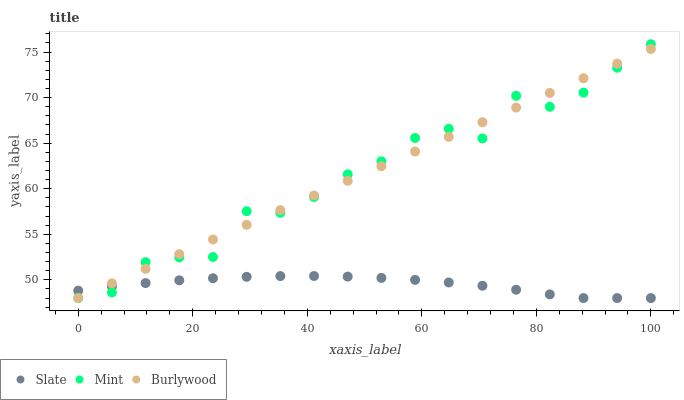Does Slate have the minimum area under the curve?
Answer yes or no. Yes. Does Burlywood have the maximum area under the curve?
Answer yes or no. Yes. Does Mint have the minimum area under the curve?
Answer yes or no. No. Does Mint have the maximum area under the curve?
Answer yes or no. No. Is Burlywood the smoothest?
Answer yes or no. Yes. Is Mint the roughest?
Answer yes or no. Yes. Is Slate the smoothest?
Answer yes or no. No. Is Slate the roughest?
Answer yes or no. No. Does Burlywood have the lowest value?
Answer yes or no. Yes. Does Mint have the highest value?
Answer yes or no. Yes. Does Slate have the highest value?
Answer yes or no. No. Does Slate intersect Burlywood?
Answer yes or no. Yes. Is Slate less than Burlywood?
Answer yes or no. No. Is Slate greater than Burlywood?
Answer yes or no. No. 